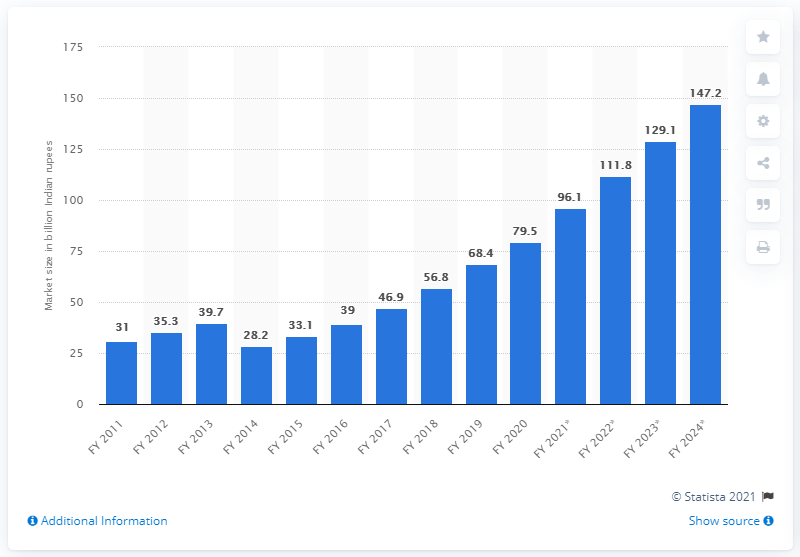List a handful of essential elements in this visual. The market size of the VFX and post-production industry in 2016 was 39... By 2024, the VFX and post-production industry was estimated to be worth approximately 147.2 billion US dollars. The VFX and post-production industry in India had a market size of approximately 79.5 in the financial year 2020. 